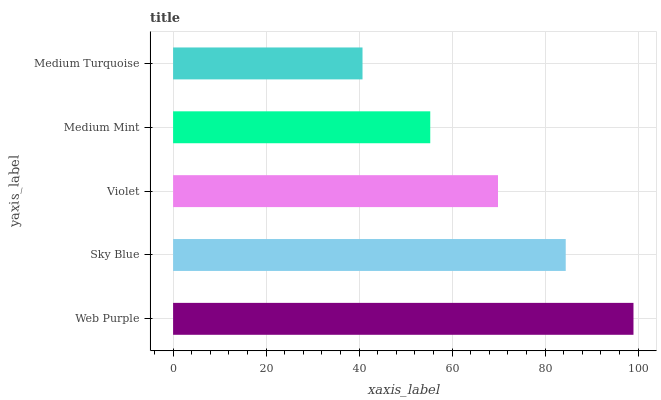Is Medium Turquoise the minimum?
Answer yes or no. Yes. Is Web Purple the maximum?
Answer yes or no. Yes. Is Sky Blue the minimum?
Answer yes or no. No. Is Sky Blue the maximum?
Answer yes or no. No. Is Web Purple greater than Sky Blue?
Answer yes or no. Yes. Is Sky Blue less than Web Purple?
Answer yes or no. Yes. Is Sky Blue greater than Web Purple?
Answer yes or no. No. Is Web Purple less than Sky Blue?
Answer yes or no. No. Is Violet the high median?
Answer yes or no. Yes. Is Violet the low median?
Answer yes or no. Yes. Is Web Purple the high median?
Answer yes or no. No. Is Medium Turquoise the low median?
Answer yes or no. No. 